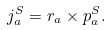Convert formula to latex. <formula><loc_0><loc_0><loc_500><loc_500>j _ { a } ^ { S } = r _ { a } \times p _ { a } ^ { S } .</formula> 